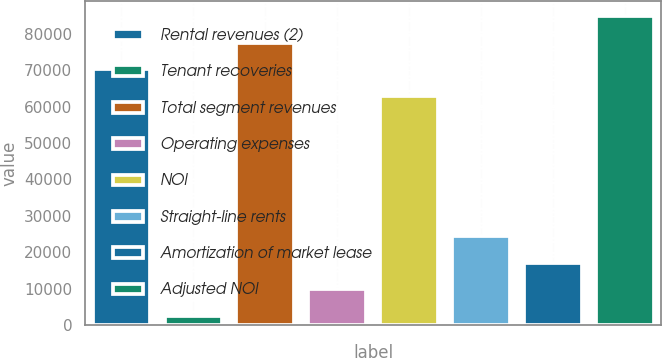<chart> <loc_0><loc_0><loc_500><loc_500><bar_chart><fcel>Rental revenues (2)<fcel>Tenant recoveries<fcel>Total segment revenues<fcel>Operating expenses<fcel>NOI<fcel>Straight-line rents<fcel>Amortization of market lease<fcel>Adjusted NOI<nl><fcel>70189<fcel>2457<fcel>77484<fcel>9752<fcel>62894<fcel>24342<fcel>17047<fcel>84779<nl></chart> 